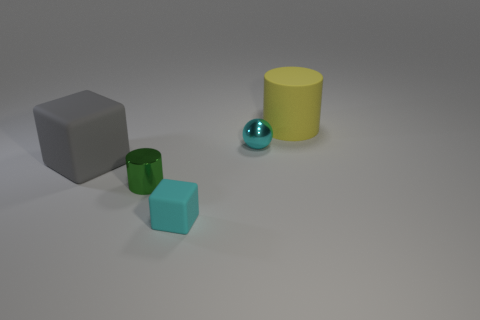Add 1 tiny green matte cylinders. How many objects exist? 6 Subtract all yellow cylinders. How many cylinders are left? 1 Subtract all cylinders. How many objects are left? 3 Subtract 2 cubes. How many cubes are left? 0 Subtract all yellow balls. Subtract all yellow blocks. How many balls are left? 1 Subtract all green cylinders. How many cyan cubes are left? 1 Subtract all rubber things. Subtract all small brown matte cylinders. How many objects are left? 2 Add 5 small cyan rubber blocks. How many small cyan rubber blocks are left? 6 Add 3 large yellow matte things. How many large yellow matte things exist? 4 Subtract 0 red spheres. How many objects are left? 5 